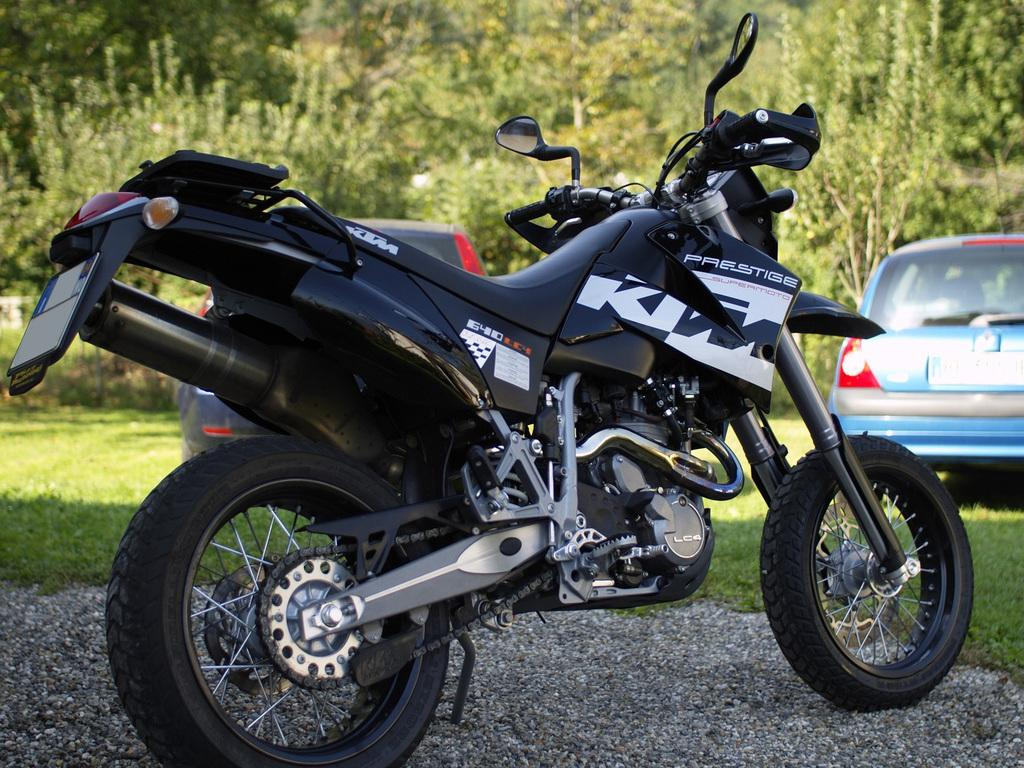What is the main object in the image? There is a bike in the image. Where is the bike located in relation to the grass? The bike is placed near the grass. What other vehicles are present in the image? There are two cars parked on the grass in the image. What can be seen in the background of the image? There are trees and plants in the background of the image. What type of cabbage is growing on the bike in the image? There is no cabbage growing on the bike in the image. Can you tell me how many horses are visible in the image? There are no horses present in the image. 